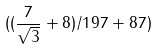<formula> <loc_0><loc_0><loc_500><loc_500>( ( \frac { 7 } { \sqrt { 3 } } + 8 ) / 1 9 7 + 8 7 )</formula> 